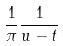Convert formula to latex. <formula><loc_0><loc_0><loc_500><loc_500>\frac { 1 } { \pi } \frac { 1 } { u - t }</formula> 